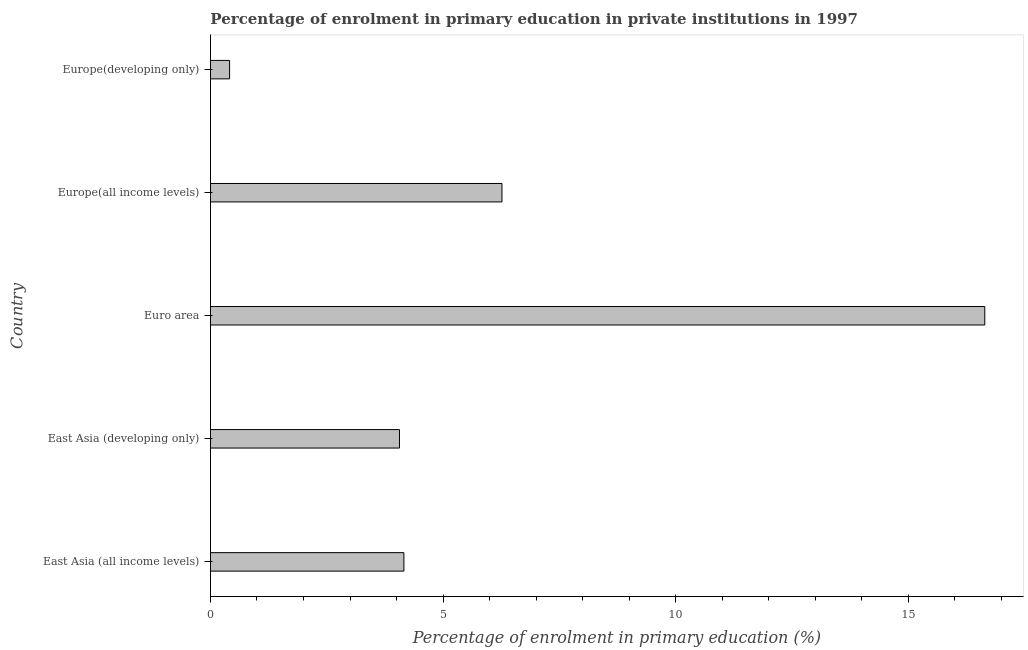Does the graph contain grids?
Provide a short and direct response. No. What is the title of the graph?
Make the answer very short. Percentage of enrolment in primary education in private institutions in 1997. What is the label or title of the X-axis?
Provide a succinct answer. Percentage of enrolment in primary education (%). What is the label or title of the Y-axis?
Provide a short and direct response. Country. What is the enrolment percentage in primary education in Euro area?
Your answer should be very brief. 16.65. Across all countries, what is the maximum enrolment percentage in primary education?
Your response must be concise. 16.65. Across all countries, what is the minimum enrolment percentage in primary education?
Your answer should be very brief. 0.41. In which country was the enrolment percentage in primary education maximum?
Make the answer very short. Euro area. In which country was the enrolment percentage in primary education minimum?
Your answer should be compact. Europe(developing only). What is the sum of the enrolment percentage in primary education?
Offer a very short reply. 31.55. What is the difference between the enrolment percentage in primary education in East Asia (all income levels) and Euro area?
Your response must be concise. -12.49. What is the average enrolment percentage in primary education per country?
Your answer should be compact. 6.31. What is the median enrolment percentage in primary education?
Keep it short and to the point. 4.16. What is the ratio of the enrolment percentage in primary education in East Asia (all income levels) to that in Europe(all income levels)?
Your answer should be compact. 0.66. What is the difference between the highest and the second highest enrolment percentage in primary education?
Give a very brief answer. 10.38. What is the difference between the highest and the lowest enrolment percentage in primary education?
Keep it short and to the point. 16.24. In how many countries, is the enrolment percentage in primary education greater than the average enrolment percentage in primary education taken over all countries?
Offer a very short reply. 1. Are all the bars in the graph horizontal?
Keep it short and to the point. Yes. How many countries are there in the graph?
Make the answer very short. 5. What is the difference between two consecutive major ticks on the X-axis?
Offer a very short reply. 5. Are the values on the major ticks of X-axis written in scientific E-notation?
Your answer should be very brief. No. What is the Percentage of enrolment in primary education (%) of East Asia (all income levels)?
Give a very brief answer. 4.16. What is the Percentage of enrolment in primary education (%) in East Asia (developing only)?
Ensure brevity in your answer.  4.06. What is the Percentage of enrolment in primary education (%) in Euro area?
Offer a very short reply. 16.65. What is the Percentage of enrolment in primary education (%) of Europe(all income levels)?
Ensure brevity in your answer.  6.27. What is the Percentage of enrolment in primary education (%) of Europe(developing only)?
Your response must be concise. 0.41. What is the difference between the Percentage of enrolment in primary education (%) in East Asia (all income levels) and East Asia (developing only)?
Your answer should be very brief. 0.1. What is the difference between the Percentage of enrolment in primary education (%) in East Asia (all income levels) and Euro area?
Ensure brevity in your answer.  -12.49. What is the difference between the Percentage of enrolment in primary education (%) in East Asia (all income levels) and Europe(all income levels)?
Provide a succinct answer. -2.11. What is the difference between the Percentage of enrolment in primary education (%) in East Asia (all income levels) and Europe(developing only)?
Provide a short and direct response. 3.75. What is the difference between the Percentage of enrolment in primary education (%) in East Asia (developing only) and Euro area?
Provide a short and direct response. -12.58. What is the difference between the Percentage of enrolment in primary education (%) in East Asia (developing only) and Europe(all income levels)?
Give a very brief answer. -2.2. What is the difference between the Percentage of enrolment in primary education (%) in East Asia (developing only) and Europe(developing only)?
Provide a succinct answer. 3.65. What is the difference between the Percentage of enrolment in primary education (%) in Euro area and Europe(all income levels)?
Ensure brevity in your answer.  10.38. What is the difference between the Percentage of enrolment in primary education (%) in Euro area and Europe(developing only)?
Ensure brevity in your answer.  16.24. What is the difference between the Percentage of enrolment in primary education (%) in Europe(all income levels) and Europe(developing only)?
Make the answer very short. 5.86. What is the ratio of the Percentage of enrolment in primary education (%) in East Asia (all income levels) to that in Euro area?
Provide a short and direct response. 0.25. What is the ratio of the Percentage of enrolment in primary education (%) in East Asia (all income levels) to that in Europe(all income levels)?
Offer a very short reply. 0.66. What is the ratio of the Percentage of enrolment in primary education (%) in East Asia (all income levels) to that in Europe(developing only)?
Offer a very short reply. 10.12. What is the ratio of the Percentage of enrolment in primary education (%) in East Asia (developing only) to that in Euro area?
Your answer should be compact. 0.24. What is the ratio of the Percentage of enrolment in primary education (%) in East Asia (developing only) to that in Europe(all income levels)?
Keep it short and to the point. 0.65. What is the ratio of the Percentage of enrolment in primary education (%) in East Asia (developing only) to that in Europe(developing only)?
Your response must be concise. 9.89. What is the ratio of the Percentage of enrolment in primary education (%) in Euro area to that in Europe(all income levels)?
Make the answer very short. 2.66. What is the ratio of the Percentage of enrolment in primary education (%) in Euro area to that in Europe(developing only)?
Provide a short and direct response. 40.51. What is the ratio of the Percentage of enrolment in primary education (%) in Europe(all income levels) to that in Europe(developing only)?
Provide a short and direct response. 15.25. 